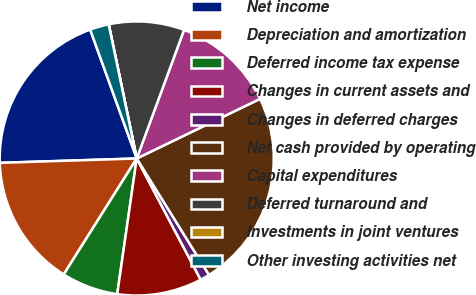<chart> <loc_0><loc_0><loc_500><loc_500><pie_chart><fcel>Net income<fcel>Depreciation and amortization<fcel>Deferred income tax expense<fcel>Changes in current assets and<fcel>Changes in deferred charges<fcel>Net cash provided by operating<fcel>Capital expenditures<fcel>Deferred turnaround and<fcel>Investments in joint ventures<fcel>Other investing activities net<nl><fcel>19.99%<fcel>15.55%<fcel>6.67%<fcel>10.0%<fcel>1.12%<fcel>23.32%<fcel>12.22%<fcel>8.89%<fcel>0.01%<fcel>2.23%<nl></chart> 